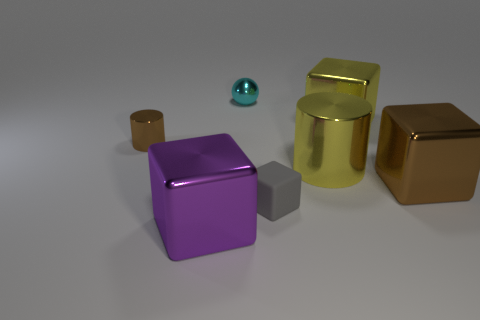Add 2 large cyan metal blocks. How many objects exist? 9 Subtract all balls. How many objects are left? 6 Subtract 0 gray cylinders. How many objects are left? 7 Subtract all large blocks. Subtract all large red metallic things. How many objects are left? 4 Add 2 purple metal blocks. How many purple metal blocks are left? 3 Add 3 large purple objects. How many large purple objects exist? 4 